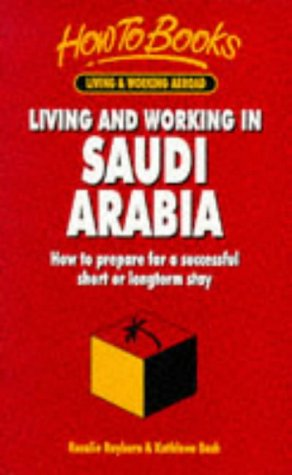Is this a child-care book? No, this book does not focus on child-care. Its primary purpose is to guide adults through the process of adapting to life and work in Saudi Arabia. 